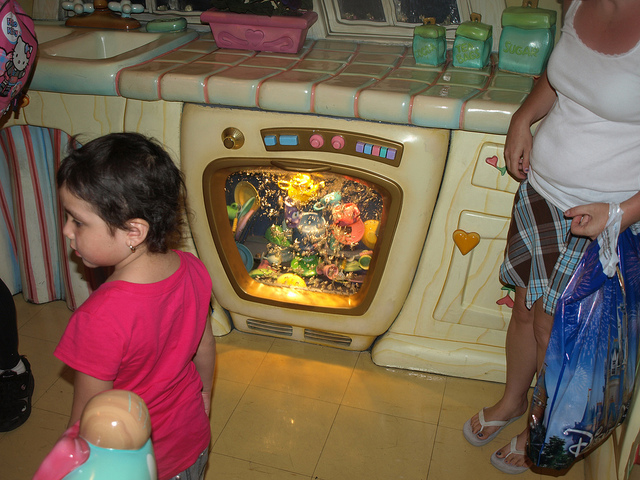Describe the overall mood or theme present in this location. The overall mood is one of enchantment and wonder, designed to appeal to children's love for fantasy. The use of vibrant colors and playful elements like the fake aquarium contributes to a theme of magical domesticity. 